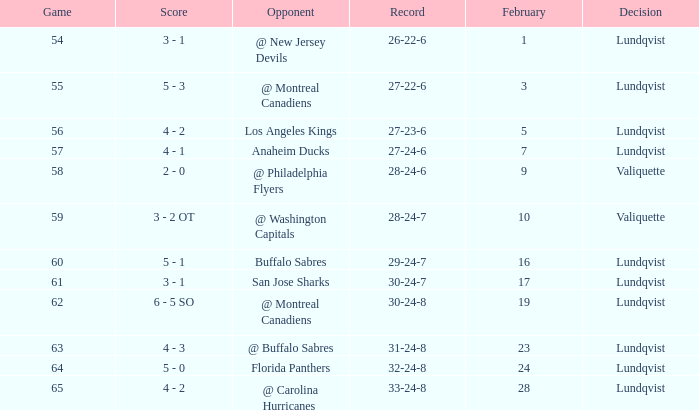What's the score for a game over 56 with a record of 29-24-7 with a lundqvist decision? 5 - 1. 